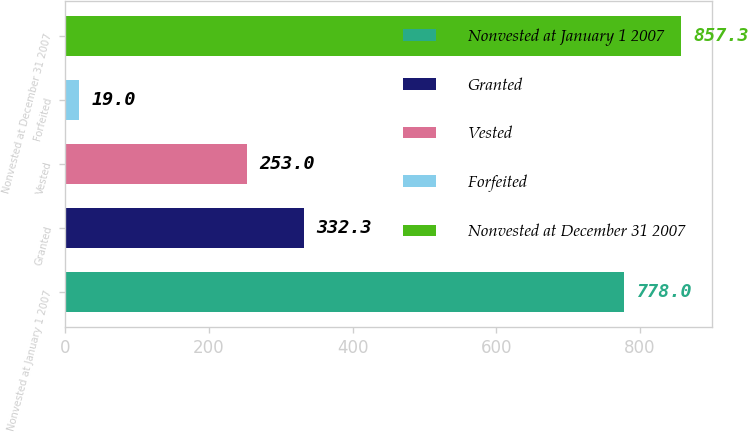<chart> <loc_0><loc_0><loc_500><loc_500><bar_chart><fcel>Nonvested at January 1 2007<fcel>Granted<fcel>Vested<fcel>Forfeited<fcel>Nonvested at December 31 2007<nl><fcel>778<fcel>332.3<fcel>253<fcel>19<fcel>857.3<nl></chart> 